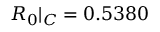Convert formula to latex. <formula><loc_0><loc_0><loc_500><loc_500>R _ { 0 } | _ { C } = 0 . 5 3 8 0</formula> 